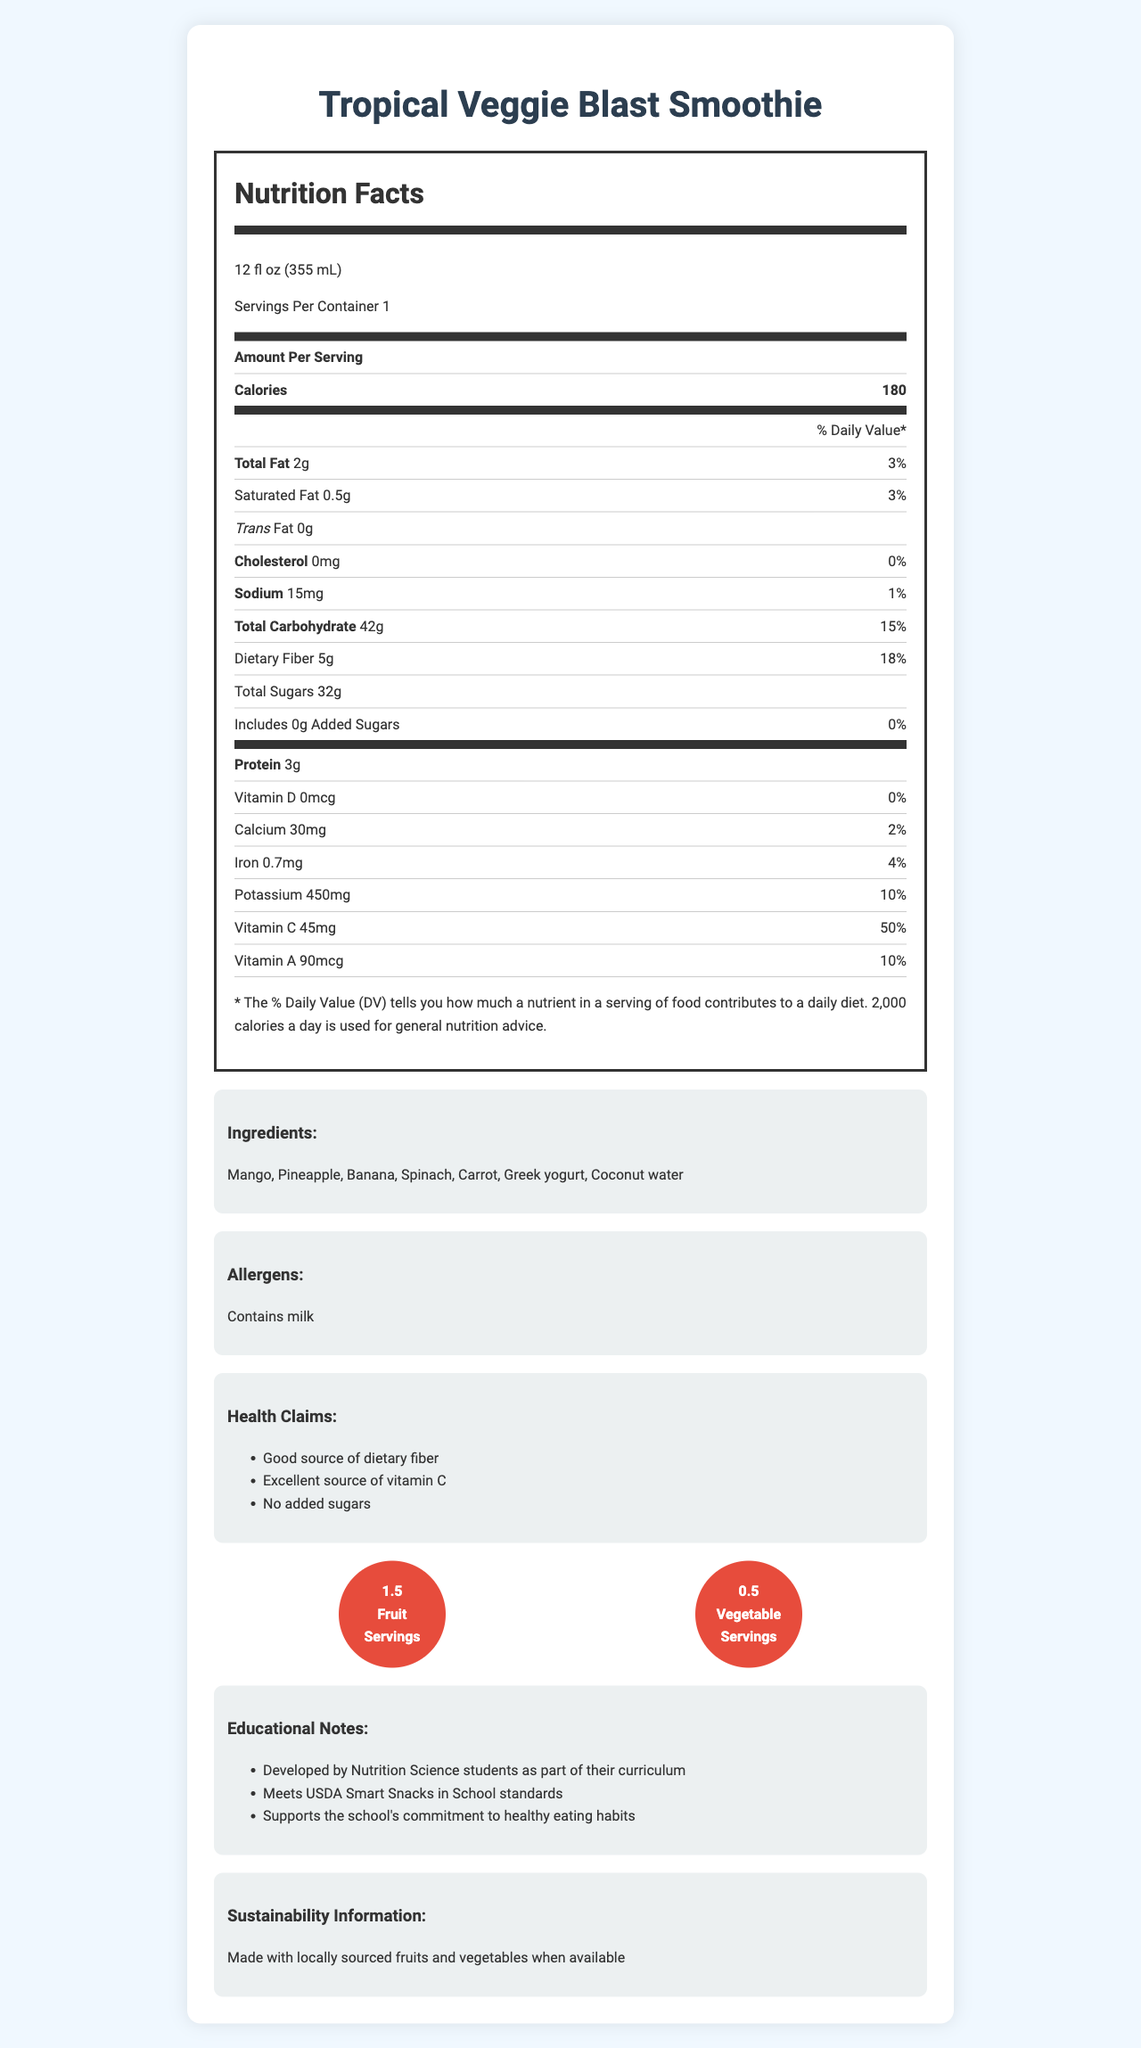what is the serving size of the smoothie? The serving size is shown at the beginning of the nutrition facts section.
Answer: 12 fl oz (355 mL) how many calories are in one serving of the smoothie? The number of calories per serving is listed directly under the serving size information.
Answer: 180 what is the total fat content per serving? The total fat content is provided in the nutrition facts table under the section labeled "Total Fat."
Answer: 2g how much dietary fiber does the smoothie contain? The amount of dietary fiber is listed in the nutrition facts table under "Dietary Fiber."
Answer: 5g does the smoothie contain any added sugars? The nutrition facts table states "Includes 0g Added Sugars," which means there are no added sugars.
Answer: No which of the following is NOT an ingredient in the smoothie? A. Pineapple B. Spinach C. Honey According to the ingredients list, the smoothie contains Mango, Pineapple, Banana, Spinach, Carrot, Greek yogurt, and Coconut water, but not Honey.
Answer: C. Honey what are the allergens present in the smoothie? A. Peanuts B. Milk C. Soy D. Eggs The allergens section lists "Contains milk."
Answer: B. Milk is the Tropical Veggie Blast Smoothie a good source of dietary fiber? The health claims section states "Good source of dietary fiber."
Answer: Yes does the smoothie meet the USDA Smart Snacks in School standards? One of the educational notes states that the smoothie meets USDA Smart Snacks in School standards.
Answer: Yes how many servings of fruit and vegetables are in the smoothie? The fruit and vegetable servings section specifies 1.5 fruit servings and 0.5 vegetable servings.
Answer: 1.5 fruit servings and 0.5 vegetable servings does the smoothie support the school's commitment to healthy eating habits? According to the educational notes, the smoothie supports the school's commitment to healthy eating habits.
Answer: Yes what is the amount of vitamin C in the smoothie? The nutrition facts table shows the vitamin C content as 45mg.
Answer: 45mg does the smoothie contain any trans fat? The nutrition facts table indicates "0g" for trans fat.
Answer: No Please describe the main idea of the document. The document provides comprehensive details about the nutritional value and ingredients of the Tropical Veggie Blast Smoothie, including its health benefits and educational context.
Answer: The document is a nutrition facts label for a student-designed smoothie called "Tropical Veggie Blast Smoothie," featuring detailed nutritional information, ingredients, allergens, health claims, fruit and vegetable servings, educational notes, and sustainability information. what percentage of the daily value for calcium does the smoothie provide? The nutrition facts table indicates that the smoothie provides 2% of the daily value for calcium.
Answer: 2% where are the fruits and vegetables in the smoothie sourced from? The document mentions that fruits and vegetables are locally sourced "when available," but it does not specify detailed sourcing locations.
Answer: Not enough information 